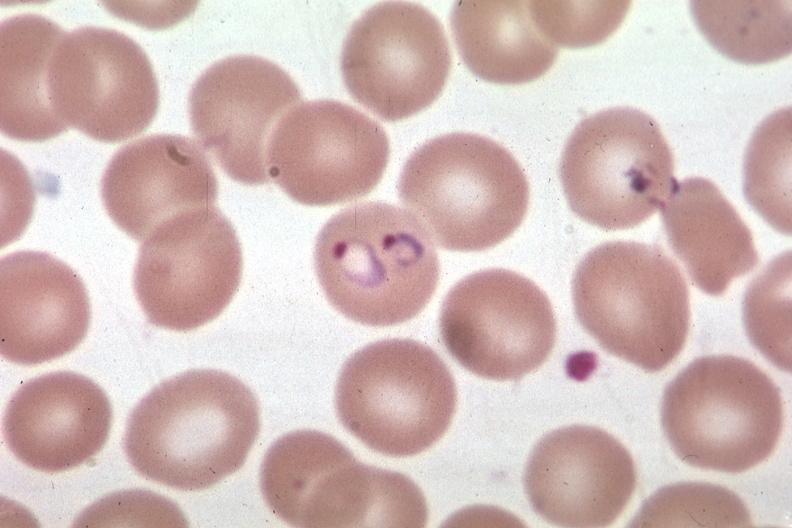s lesion of myocytolysis present?
Answer the question using a single word or phrase. No 